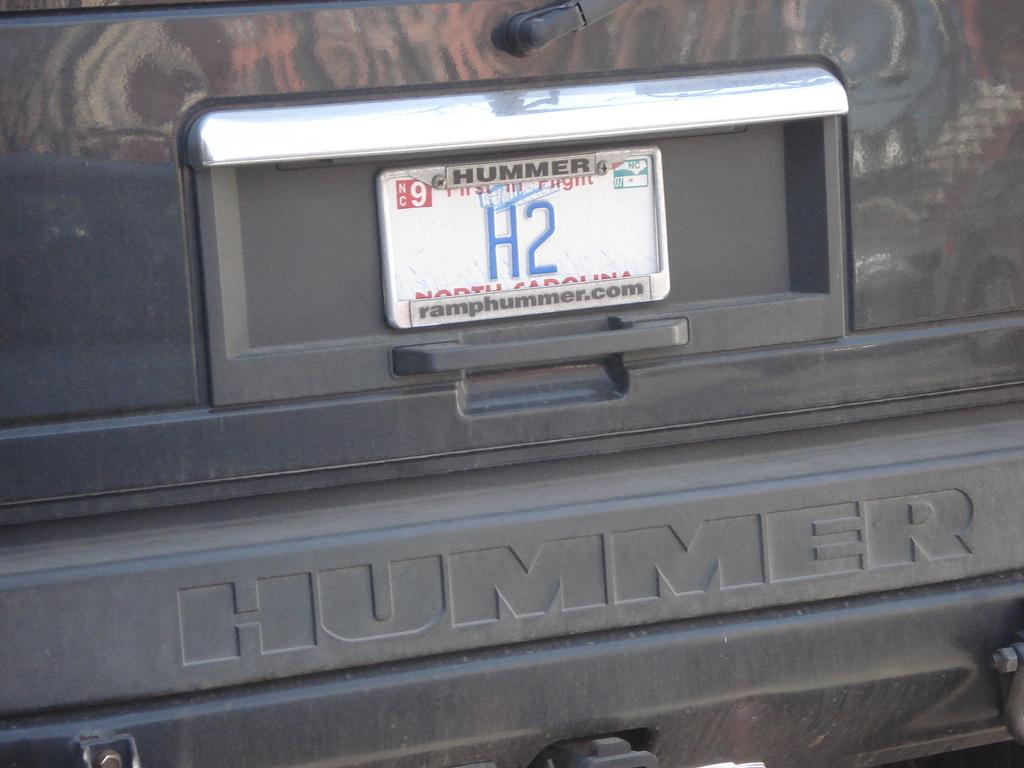What type of vehicle is this?
Make the answer very short. Hummer. What is the license plate number?
Your response must be concise. H2. 